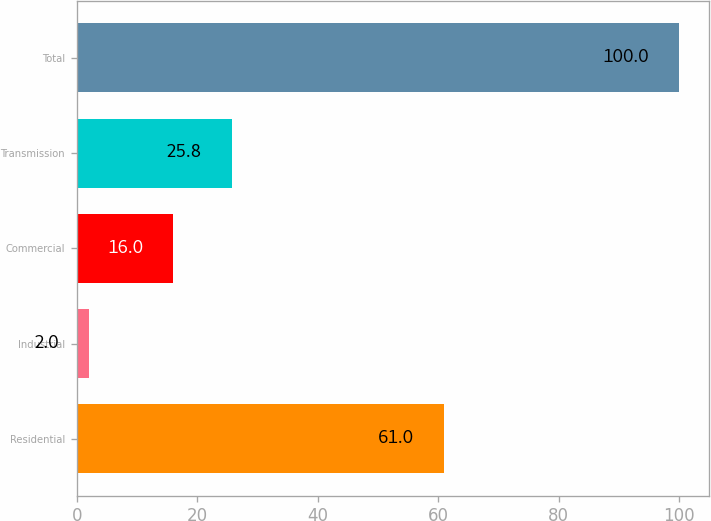Convert chart. <chart><loc_0><loc_0><loc_500><loc_500><bar_chart><fcel>Residential<fcel>Industrial<fcel>Commercial<fcel>Transmission<fcel>Total<nl><fcel>61<fcel>2<fcel>16<fcel>25.8<fcel>100<nl></chart> 